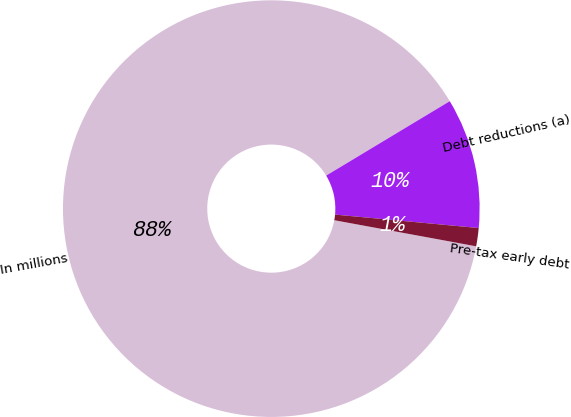<chart> <loc_0><loc_0><loc_500><loc_500><pie_chart><fcel>In millions<fcel>Debt reductions (a)<fcel>Pre-tax early debt<nl><fcel>88.48%<fcel>10.11%<fcel>1.41%<nl></chart> 